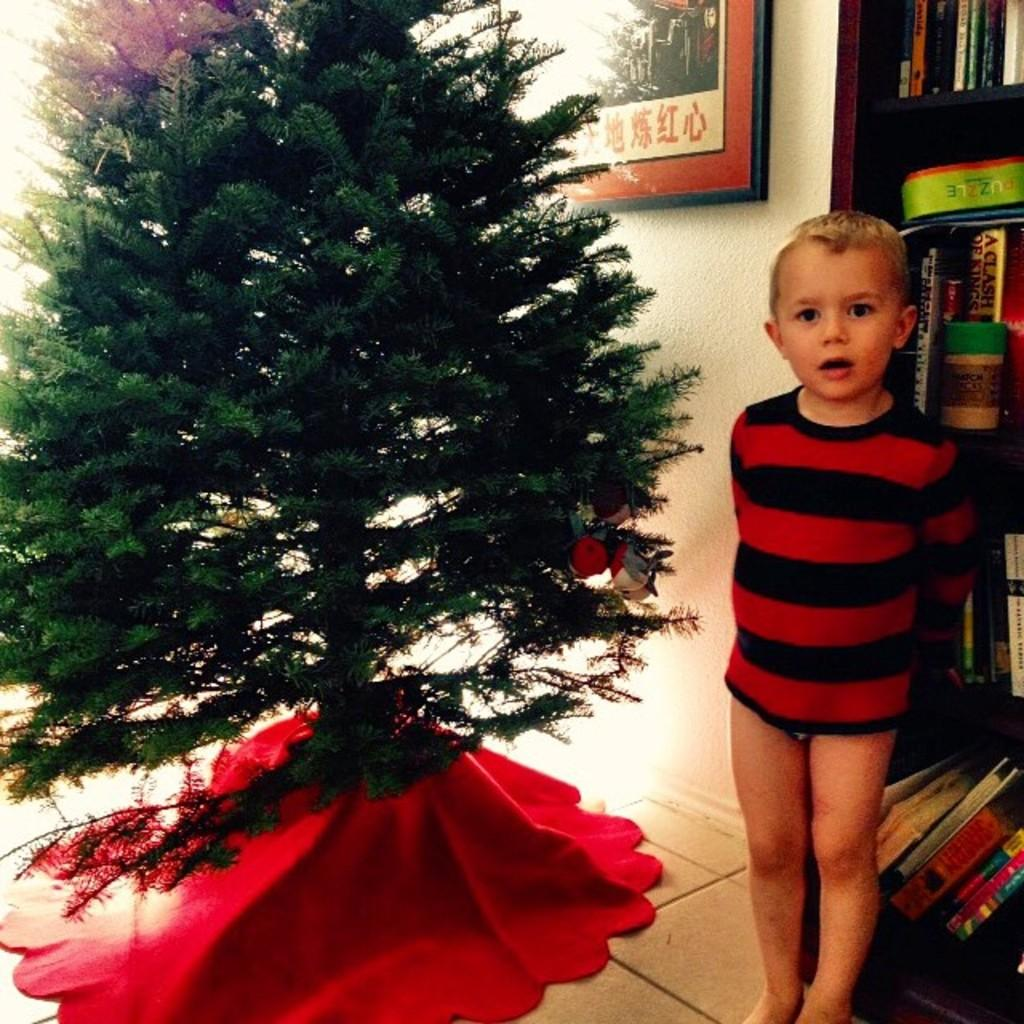Who is present in the image? There is a boy in the image. What is the main decoration in the image? There is a Christmas tree in the image. What can be seen in the background of the image? There is a wall, a photo frame, and books in the background of the image. What type of yarn is being used to decorate the farm in the image? There is no farm or yarn present in the image. 